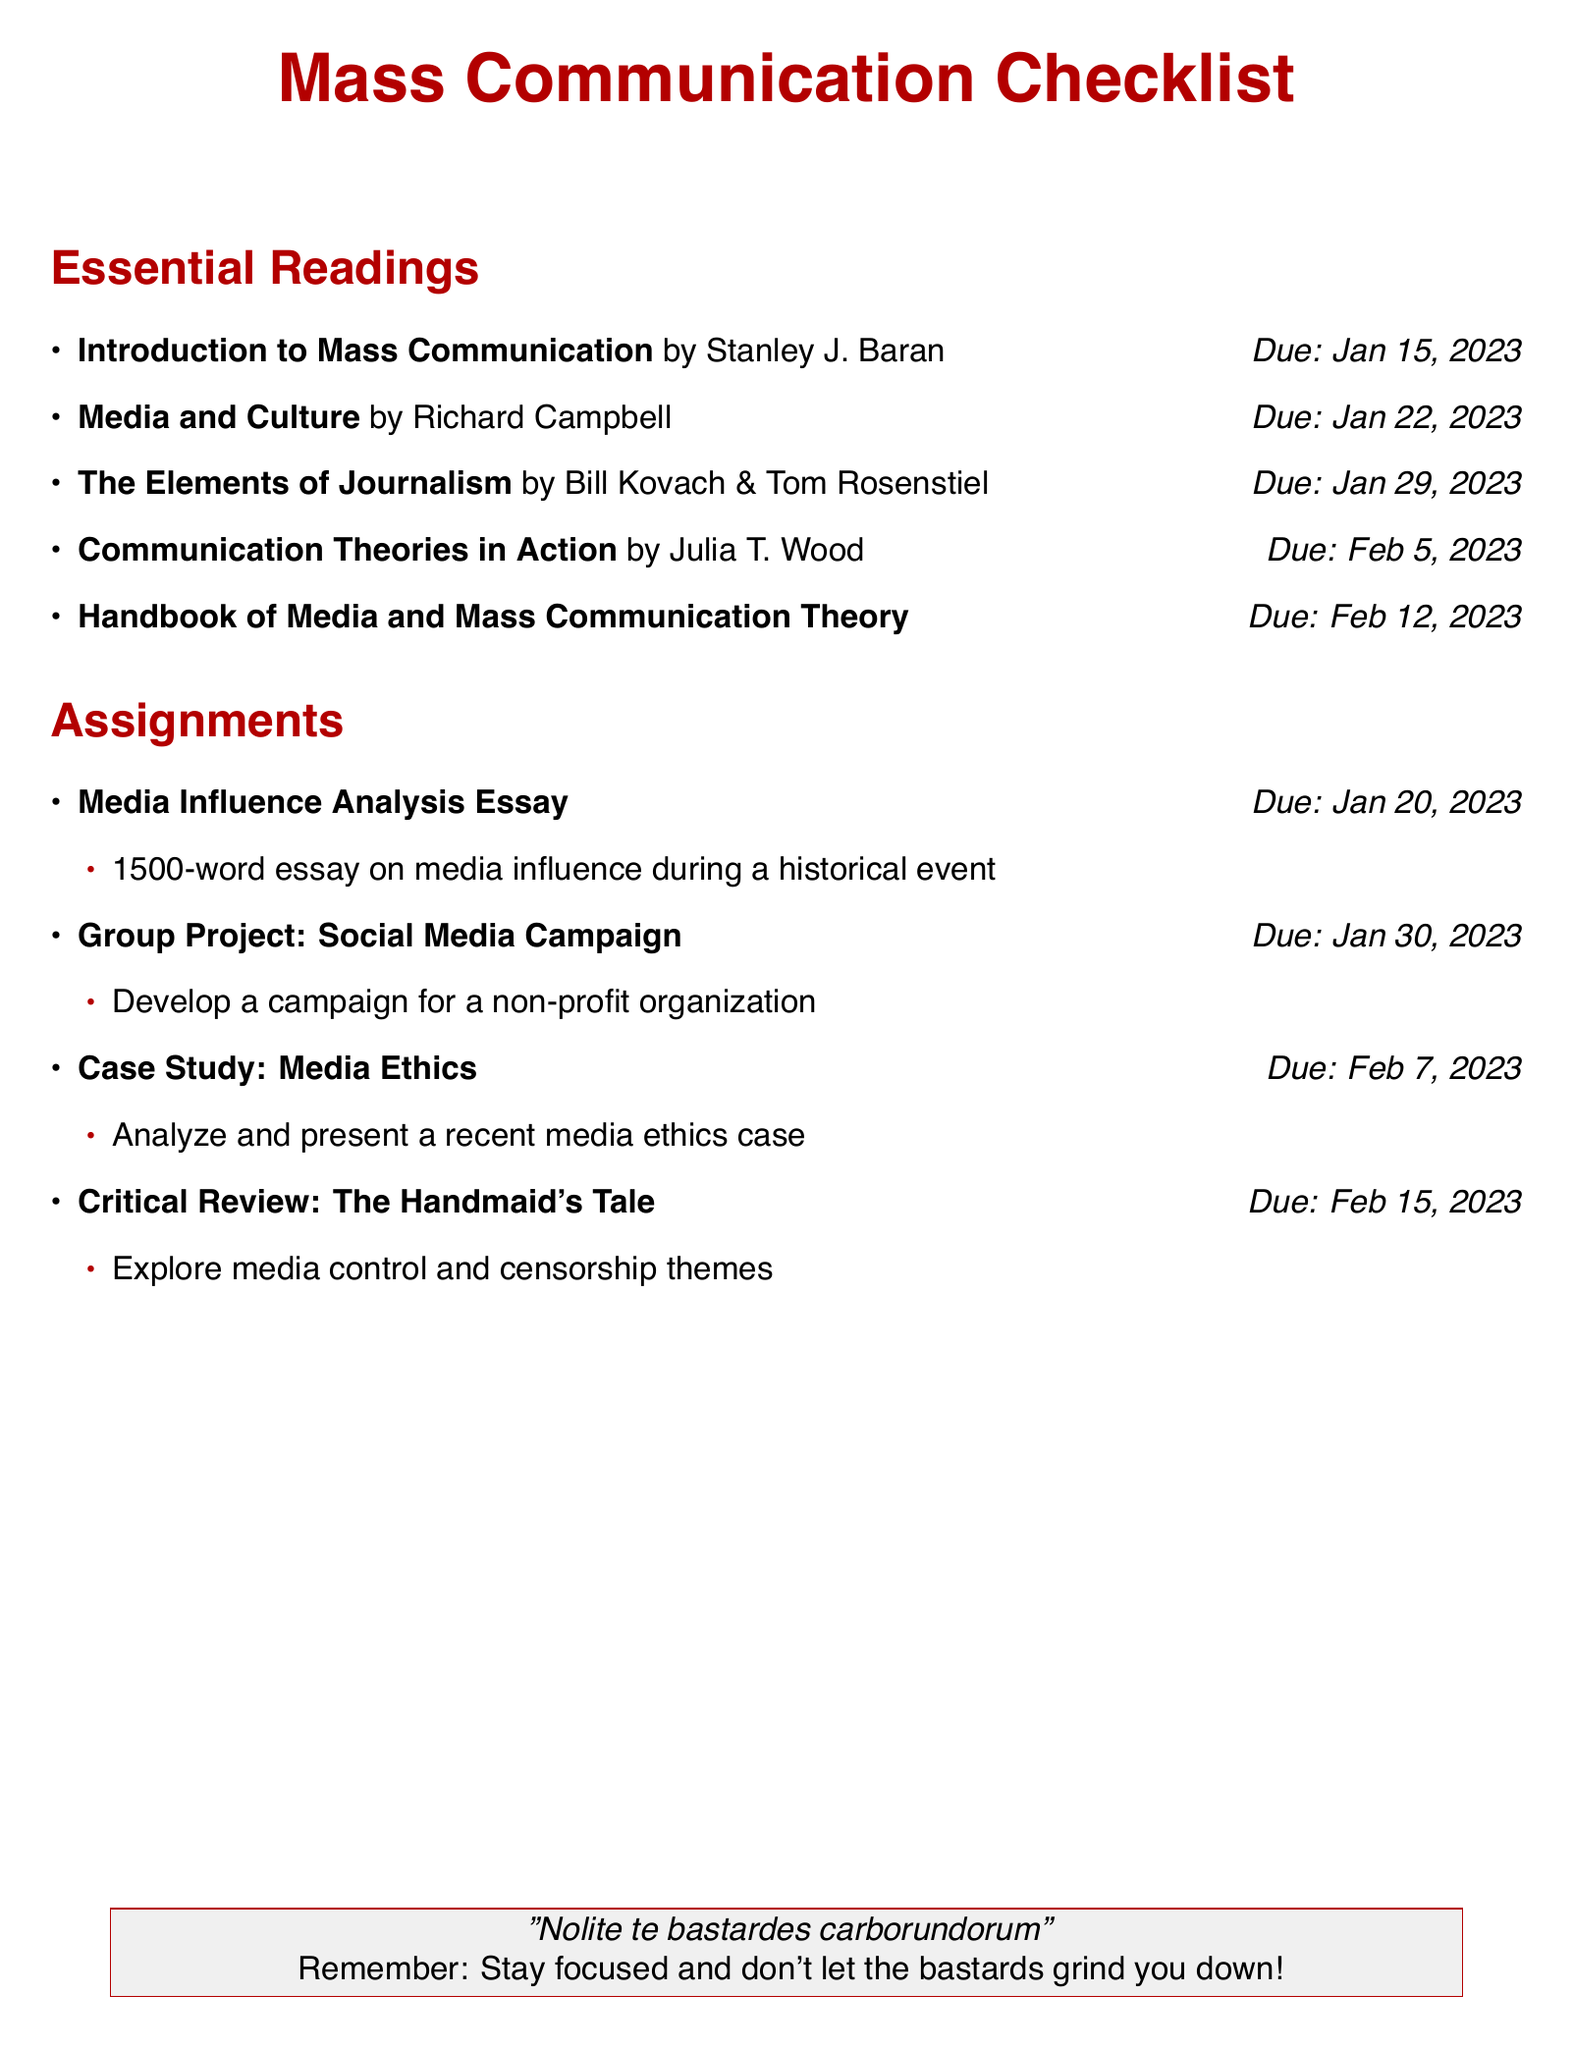What is the first reading assignment? The first reading is listed under "Essential Readings" and it is titled "Introduction to Mass Communication".
Answer: Introduction to Mass Communication What is the due date for the "Media Influence Analysis Essay"? The due date for this assignment is mentioned next to the title, which is January 20, 2023.
Answer: Jan 20, 2023 Which reading is due on February 5, 2023? By checking the due dates listed in the "Essential Readings", the reading due on February 5 is "Communication Theories in Action".
Answer: Communication Theories in Action What is the word count requirement for the "Media Influence Analysis Essay"? The document specifies that the essay should be a 1500-word essay.
Answer: 1500-word What theme is explored in the "Critical Review: The Handmaid's Tale"? The theme is listed in the description of the assignment, which mentions media control and censorship.
Answer: Media control and censorship How many assignments are due in January 2023? By reviewing the assignments listed, there are three assignments due in January.
Answer: Three What type of project is due on January 30, 2023? The project type is specified as a "Group Project: Social Media Campaign" in the assignments section.
Answer: Group Project: Social Media Campaign Which book is authored by Richard Campbell? This question pertains to the "Essential Readings", where the title by Richard Campbell is mentioned.
Answer: Media and Culture What is the last assignment listed? Looking at the assignments section, the last assignment mentioned is "Critical Review: The Handmaid's Tale".
Answer: Critical Review: The Handmaid's Tale 